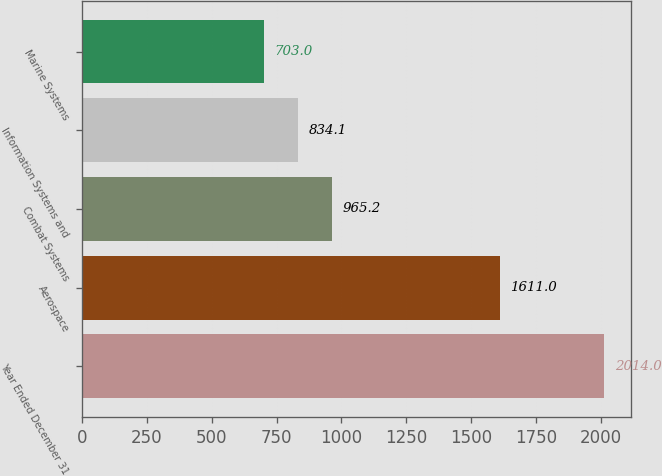Convert chart to OTSL. <chart><loc_0><loc_0><loc_500><loc_500><bar_chart><fcel>Year Ended December 31<fcel>Aerospace<fcel>Combat Systems<fcel>Information Systems and<fcel>Marine Systems<nl><fcel>2014<fcel>1611<fcel>965.2<fcel>834.1<fcel>703<nl></chart> 